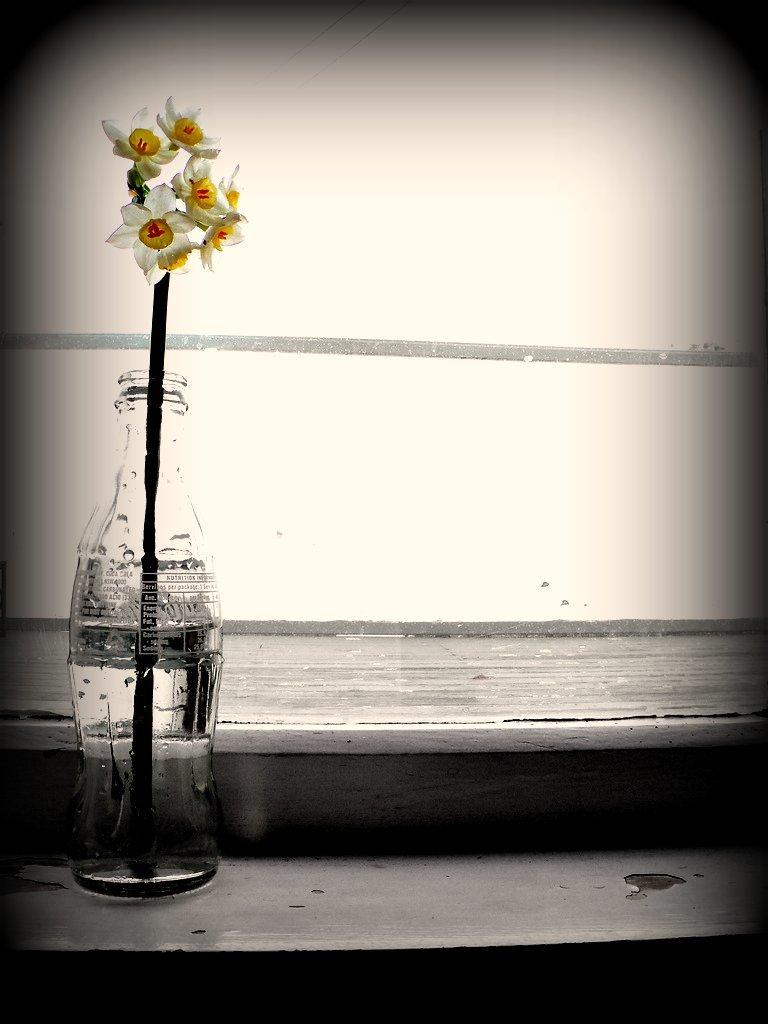What object is visible in the image? There is a bottle in the image. Where is the bottle placed? The bottle is placed on a wooden platform. What is inside the bottle? There is a stick with flowers inside the bottle. What can be seen in the background of the image? There is a wall in the background of the image. Reasoning: Let' Let's think step by step in order to produce the conversation. We start by identifying the main object in the image, which is the bottle. Then, we describe the location of the bottle and its contents, which are flowers on a stick. Finally, we mention the background element, which is a wall. Each question is designed to elicit a specific detail about the image that is known from the provided facts. Absurd Question/Answer: What type of note is attached to the flowers in the image? There is no note attached to the flowers in the image. How does the parent feel about the flowers in the image? There is no information about a parent or their feelings in the image. 